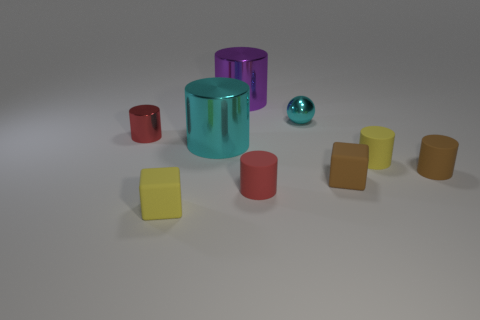There is a brown block; is its size the same as the cyan thing that is in front of the tiny red metallic cylinder? The size of the brown block is not the same as the cyan object. The cyan object appears to be a much larger cylindrical shape compared to the smaller, cube-shaped brown block positioned near the red metallic cylinder, which by description is tiny. 